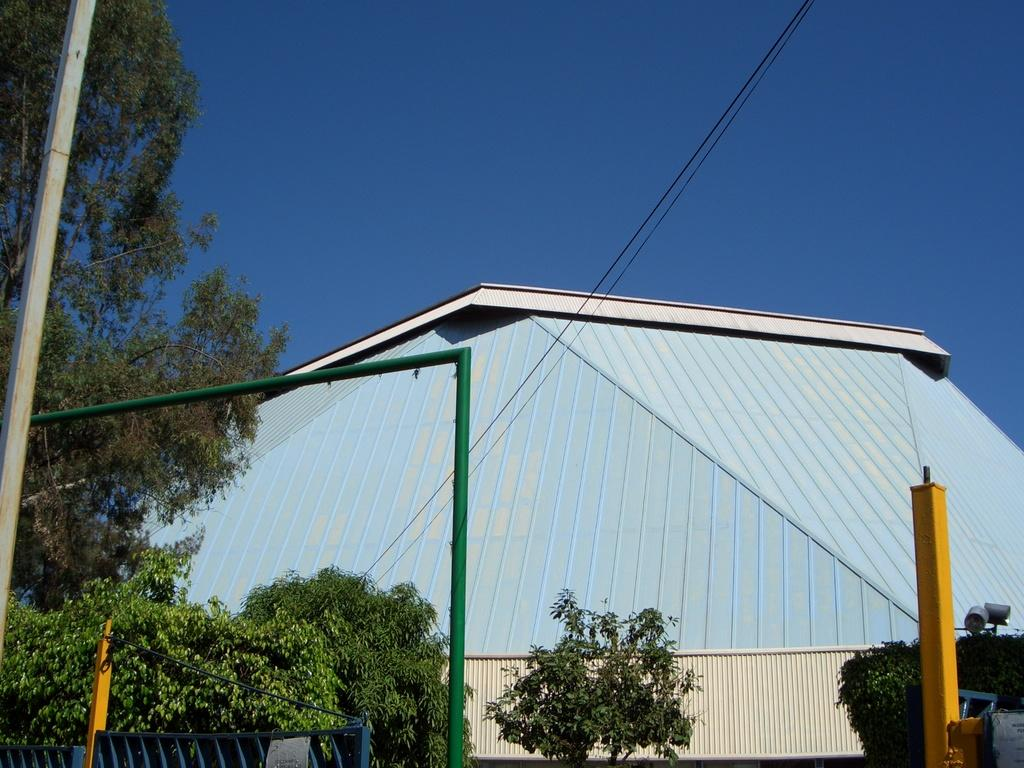What is located in the center of the image? There are plants and poles in the center of the image. What can be seen in the background of the image? There is a building in the background of the image. What is in front of the building? There are wires in front of the building. What year is depicted in the image? The image does not depict a specific year; it is a photograph of a scene that could have been taken at any time. Can you see any fog in the image? There is no fog visible in the image. 